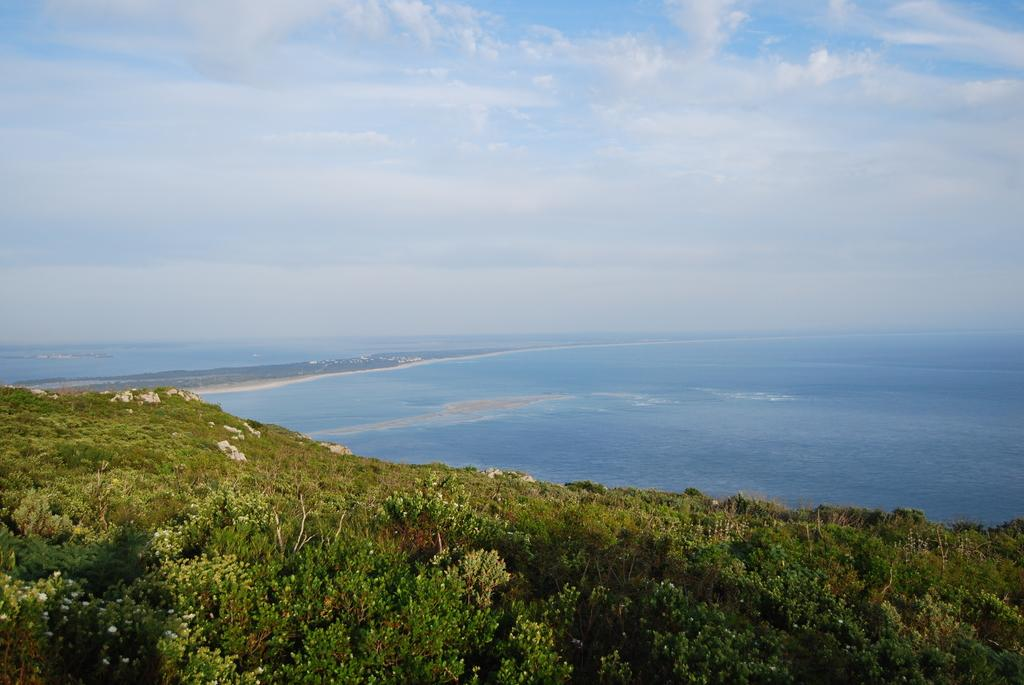What type of vegetation can be seen in the image? There are trees in the image. What natural element is visible in the image besides the trees? There is water visible in the image. What part of the sky is visible in the image? The sky is visible in the image. What can be seen in the sky in the image? Clouds are present in the sky. What type of appliance can be seen floating on the water in the image? There is no appliance present in the image; it only features trees, water, and clouds in the sky. 